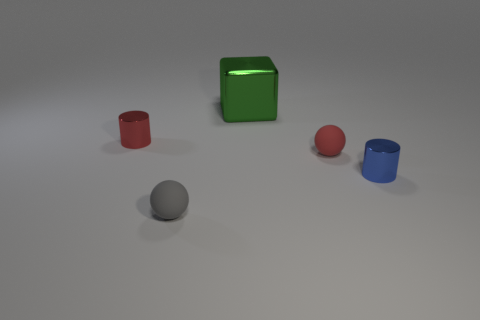Are there any other things that have the same size as the cube?
Provide a short and direct response. No. Is the number of large green objects that are on the left side of the small gray ball the same as the number of tiny blue objects that are left of the big shiny block?
Make the answer very short. Yes. There is a small matte sphere to the right of the green metal object; what is its color?
Provide a short and direct response. Red. Are there the same number of tiny red rubber balls that are in front of the red sphere and metallic things?
Your answer should be very brief. No. How many other objects are the same shape as the large metallic object?
Offer a very short reply. 0. What number of metallic things are behind the red matte sphere?
Your answer should be compact. 2. There is a object that is in front of the tiny red rubber ball and to the right of the large green thing; what is its size?
Provide a short and direct response. Small. Are any red things visible?
Provide a succinct answer. Yes. How many other objects are the same size as the red matte ball?
Give a very brief answer. 3. There is a tiny rubber sphere that is behind the tiny blue cylinder; does it have the same color as the tiny cylinder that is in front of the red metallic cylinder?
Make the answer very short. No. 